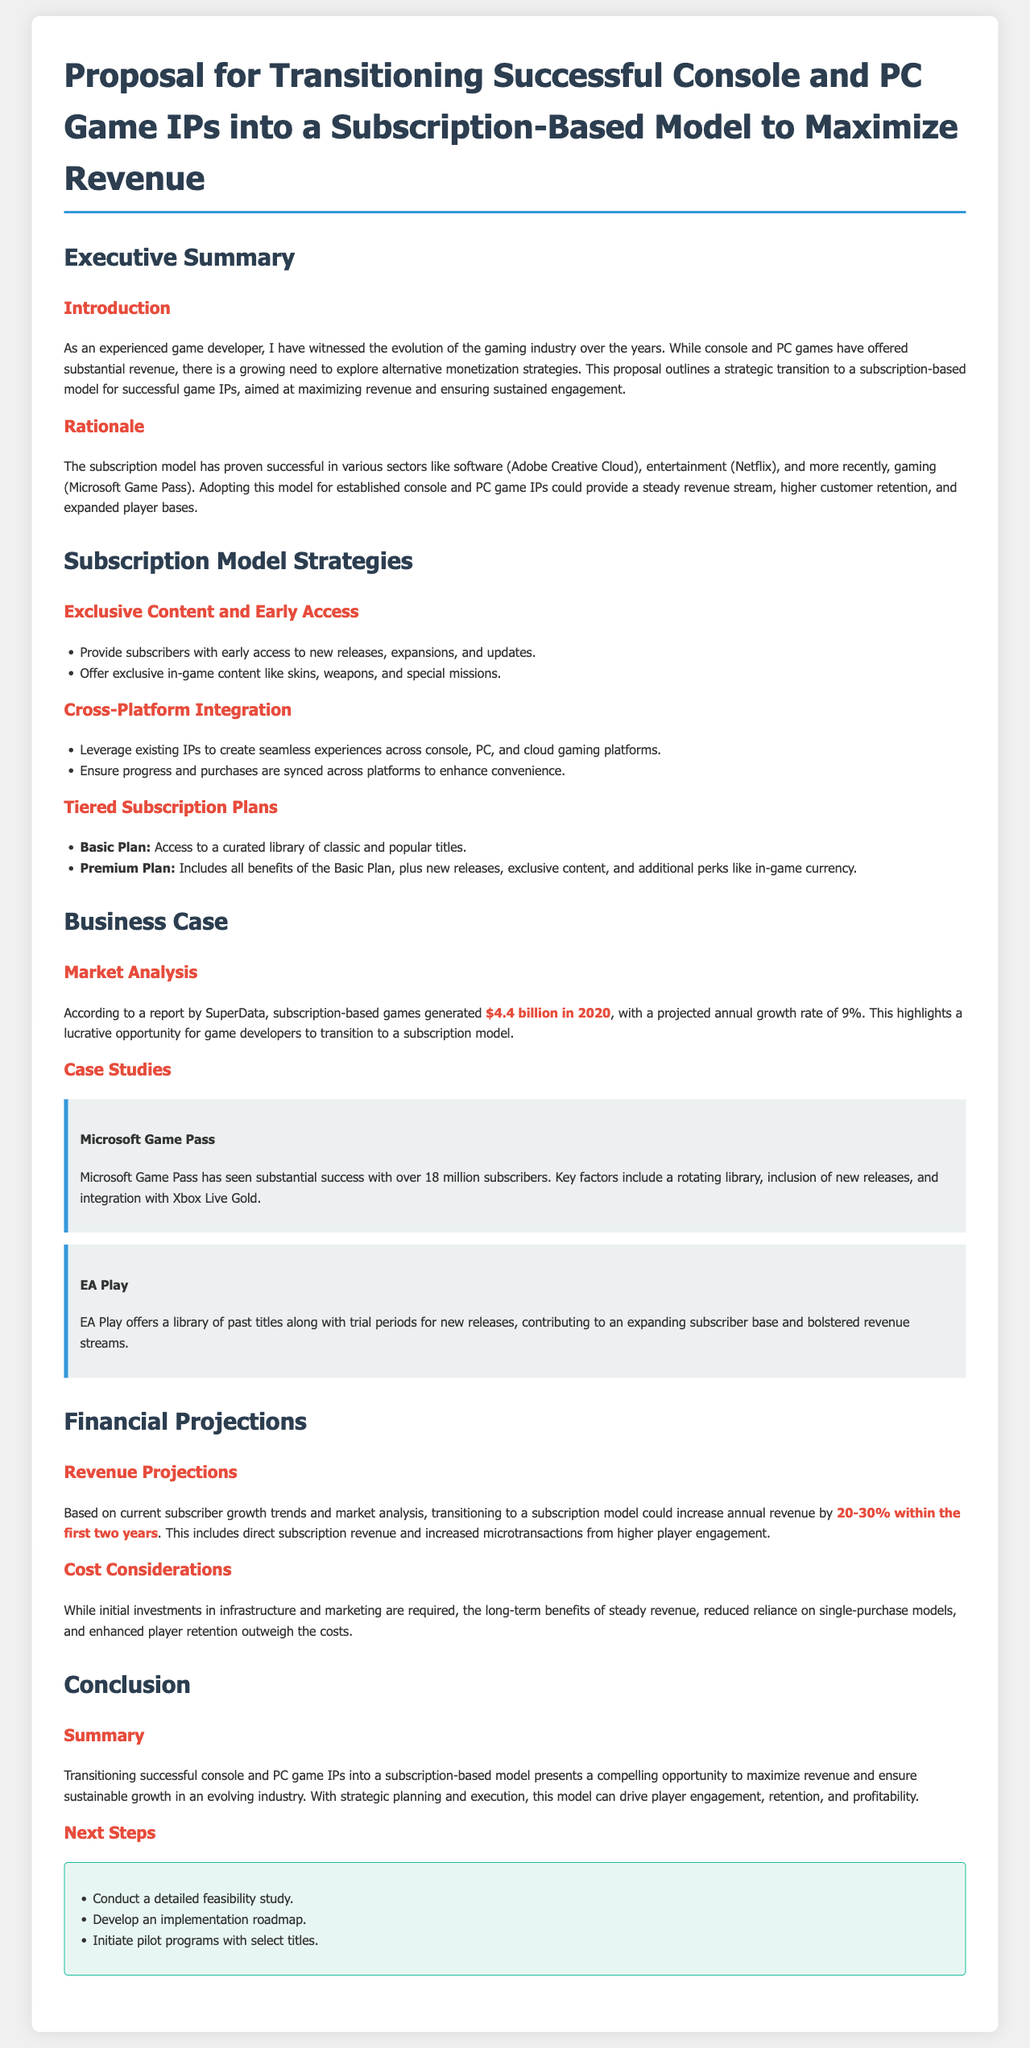What is the proposed revenue increase percentage? The projected increase in annual revenue is mentioned as 20-30% within the first two years.
Answer: 20-30% What successful subscription model is mentioned in the document? The document refers to Microsoft Game Pass as a successful example of a subscription model in gaming.
Answer: Microsoft Game Pass What year generated $4.4 billion in subscription-based games? The year when subscription-based games generated $4.4 billion is stated as 2020.
Answer: 2020 What is a key strategy for subscriber retention listed in the proposal? The proposal emphasizes "exclusive in-game content" as a strategy for retaining subscribers.
Answer: Exclusive in-game content What is the main rationale behind transitioning to a subscription model? The rationale focuses on providing a steady revenue stream and higher customer retention.
Answer: Steady revenue stream Which tiered plan includes new releases? The plan that includes new releases along with other benefits is called the Premium Plan.
Answer: Premium Plan What will be the first step in the proposed next steps? The first step detailed in the next steps is to conduct a detailed feasibility study.
Answer: Conduct a detailed feasibility study What beneficial integration is mentioned for subscribers across platforms? The proposal highlights "cross-platform integration" for enhancing convenience for users.
Answer: Cross-platform integration What does EA Play contribute to according to the case study? EA Play contributes to an expanding subscriber base and bolstered revenue streams.
Answer: Expanding subscriber base 